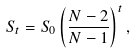Convert formula to latex. <formula><loc_0><loc_0><loc_500><loc_500>S _ { t } = S _ { 0 } \left ( \frac { N - 2 } { N - 1 } \right ) ^ { t } ,</formula> 